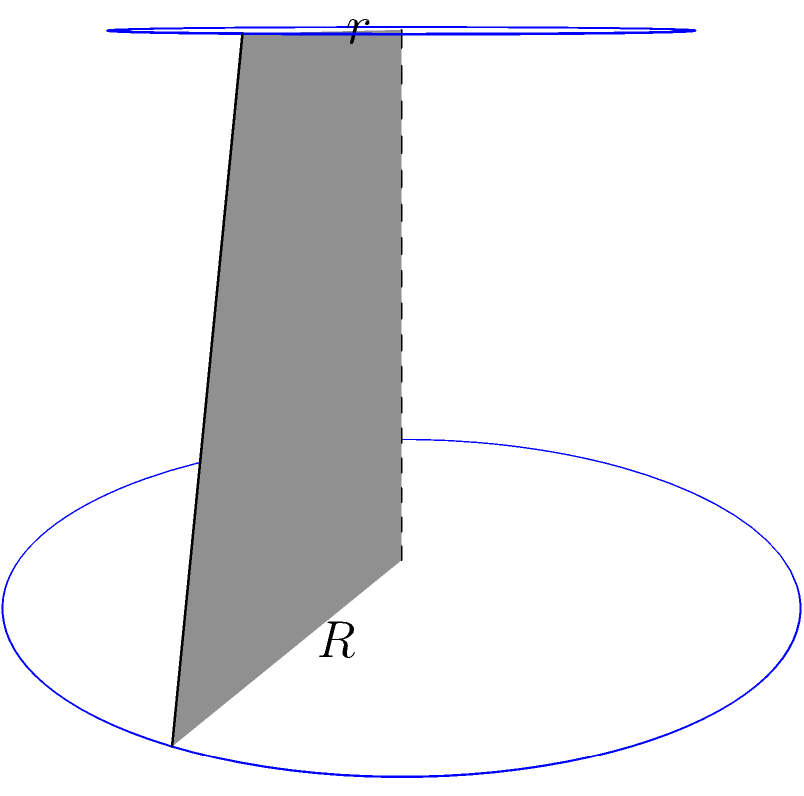As a data scientist working on 3D object recognition, you encounter a truncated cone in your dataset. Calculate the volume of this truncated cone given that its lower radius $R = 3$ units, upper radius $r = 2$ units, and height $h = 4$ units. Round your answer to two decimal places. To calculate the volume of a truncated cone, we can use the following formula:

$$V = \frac{1}{3}\pi h(R^2 + r^2 + Rr)$$

Where:
- $V$ is the volume
- $h$ is the height
- $R$ is the radius of the base
- $r$ is the radius of the top

Let's substitute the given values:

$h = 4$
$R = 3$
$r = 2$

Now, let's calculate step by step:

1) $V = \frac{1}{3}\pi \cdot 4(3^2 + 2^2 + 3 \cdot 2)$

2) $V = \frac{4\pi}{3}(9 + 4 + 6)$

3) $V = \frac{4\pi}{3}(19)$

4) $V = \frac{76\pi}{3}$

5) $V \approx 79.76$ (rounded to two decimal places)

Therefore, the volume of the truncated cone is approximately 79.76 cubic units.
Answer: 79.76 cubic units 